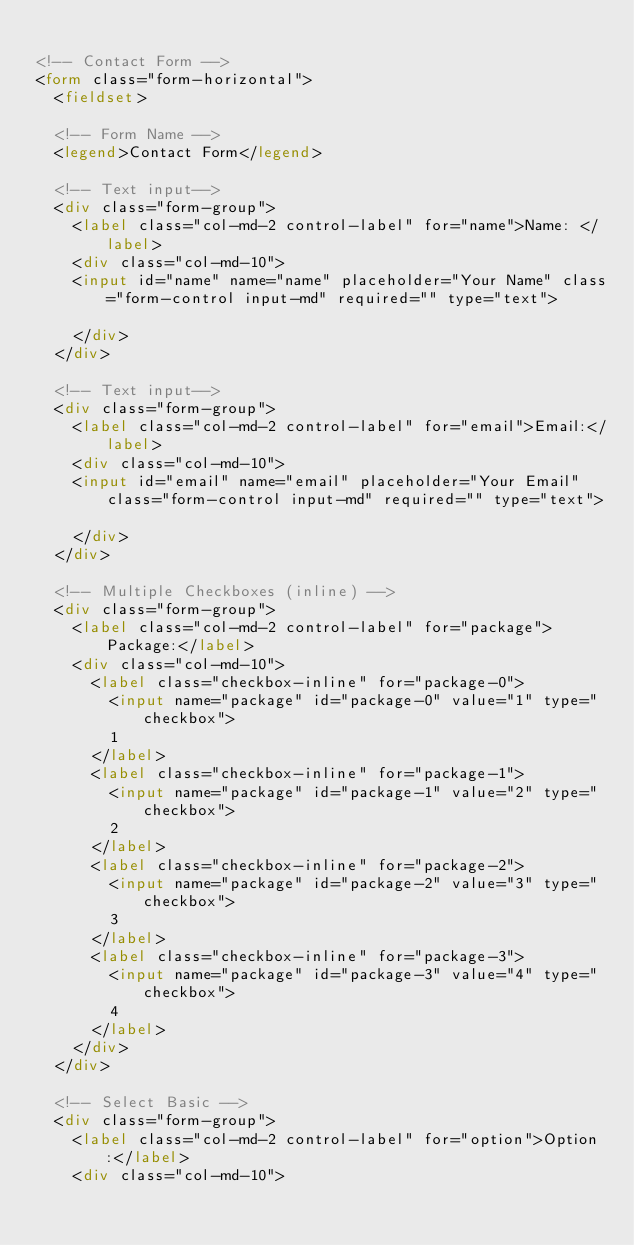<code> <loc_0><loc_0><loc_500><loc_500><_HTML_>
<!-- Contact Form -->
<form class="form-horizontal">
  <fieldset>

  <!-- Form Name -->
  <legend>Contact Form</legend>

  <!-- Text input-->
  <div class="form-group">
    <label class="col-md-2 control-label" for="name">Name: </label>
    <div class="col-md-10">
    <input id="name" name="name" placeholder="Your Name" class="form-control input-md" required="" type="text">

    </div>
  </div>

  <!-- Text input-->
  <div class="form-group">
    <label class="col-md-2 control-label" for="email">Email:</label>
    <div class="col-md-10">
    <input id="email" name="email" placeholder="Your Email" class="form-control input-md" required="" type="text">

    </div>
  </div>

  <!-- Multiple Checkboxes (inline) -->
  <div class="form-group">
    <label class="col-md-2 control-label" for="package">Package:</label>
    <div class="col-md-10">
      <label class="checkbox-inline" for="package-0">
        <input name="package" id="package-0" value="1" type="checkbox">
        1
      </label>
      <label class="checkbox-inline" for="package-1">
        <input name="package" id="package-1" value="2" type="checkbox">
        2
      </label>
      <label class="checkbox-inline" for="package-2">
        <input name="package" id="package-2" value="3" type="checkbox">
        3
      </label>
      <label class="checkbox-inline" for="package-3">
        <input name="package" id="package-3" value="4" type="checkbox">
        4
      </label>
    </div>
  </div>

  <!-- Select Basic -->
  <div class="form-group">
    <label class="col-md-2 control-label" for="option">Option:</label>
    <div class="col-md-10"></code> 